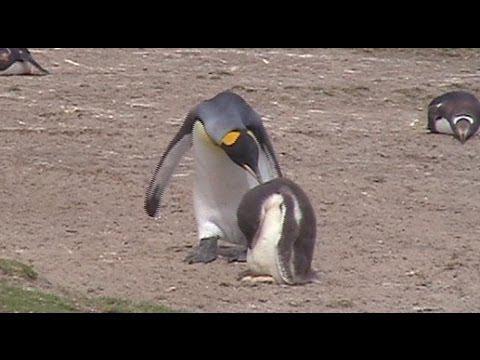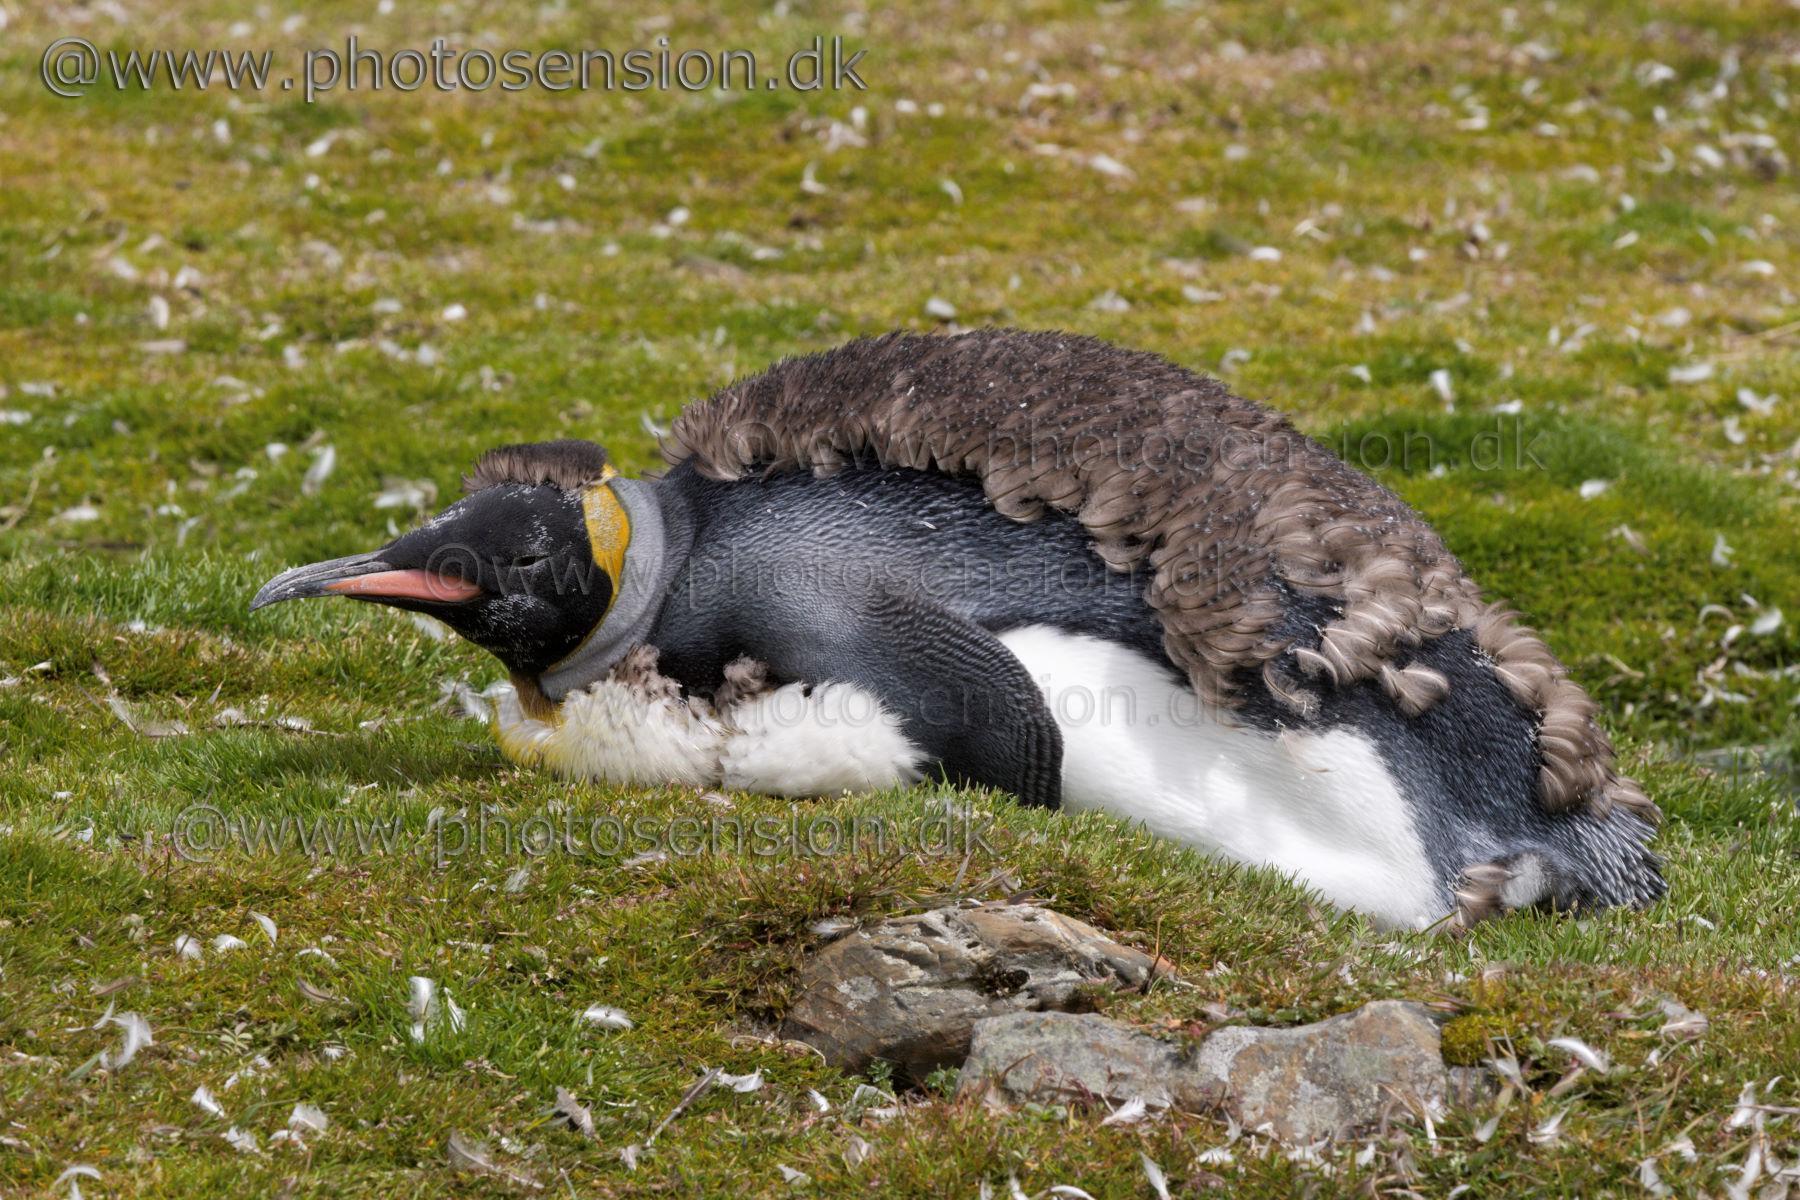The first image is the image on the left, the second image is the image on the right. Given the left and right images, does the statement "One image has a penguin surrounded by grass and rocks." hold true? Answer yes or no. Yes. The first image is the image on the left, the second image is the image on the right. Evaluate the accuracy of this statement regarding the images: "At least one of the images includes a penguin that is lying down.". Is it true? Answer yes or no. Yes. 